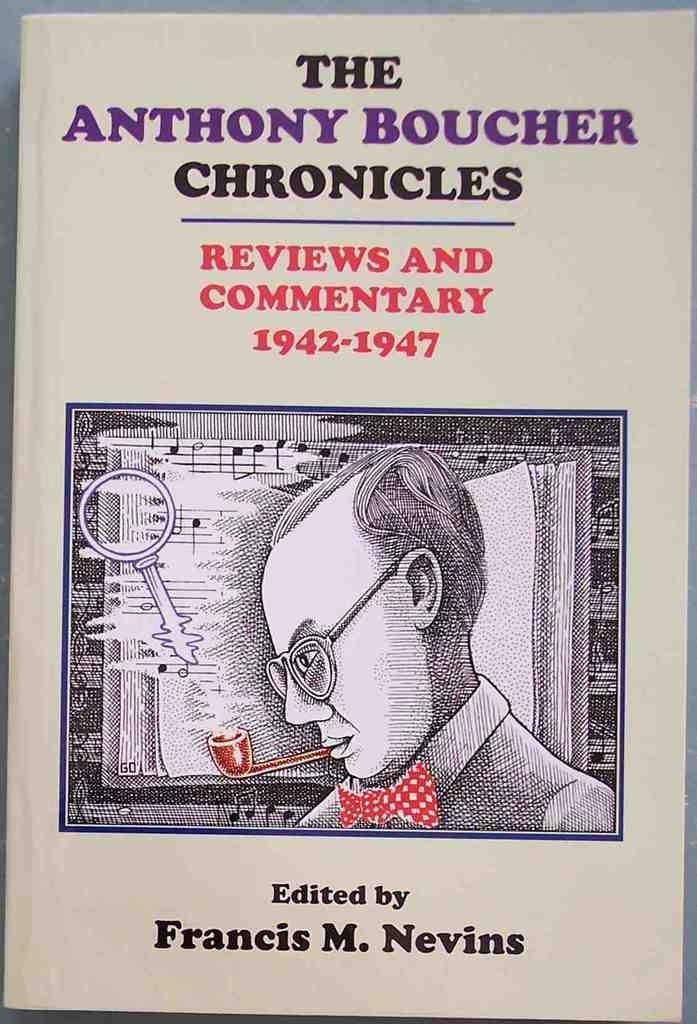<image>
Create a compact narrative representing the image presented. Francis Nevins creates a book about Anthony Boucher's life, spanning five years. 